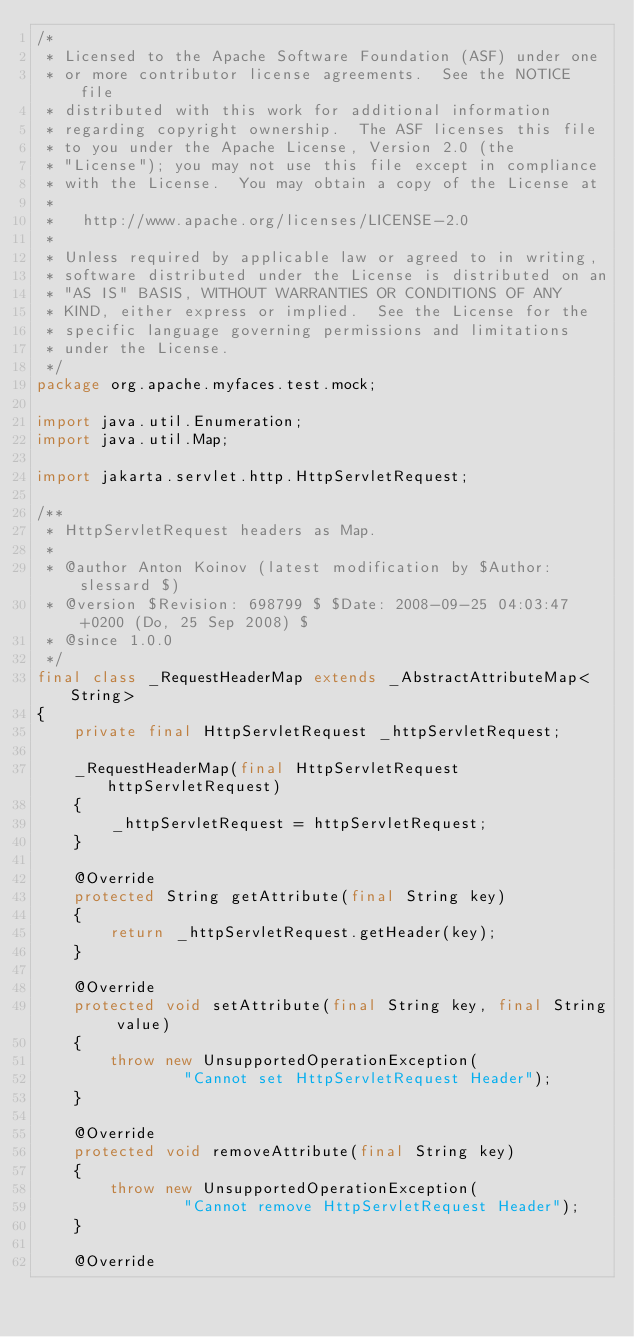Convert code to text. <code><loc_0><loc_0><loc_500><loc_500><_Java_>/*
 * Licensed to the Apache Software Foundation (ASF) under one
 * or more contributor license agreements.  See the NOTICE file
 * distributed with this work for additional information
 * regarding copyright ownership.  The ASF licenses this file
 * to you under the Apache License, Version 2.0 (the
 * "License"); you may not use this file except in compliance
 * with the License.  You may obtain a copy of the License at
 *
 *   http://www.apache.org/licenses/LICENSE-2.0
 *
 * Unless required by applicable law or agreed to in writing,
 * software distributed under the License is distributed on an
 * "AS IS" BASIS, WITHOUT WARRANTIES OR CONDITIONS OF ANY
 * KIND, either express or implied.  See the License for the
 * specific language governing permissions and limitations
 * under the License.
 */
package org.apache.myfaces.test.mock;

import java.util.Enumeration;
import java.util.Map;

import jakarta.servlet.http.HttpServletRequest;

/**
 * HttpServletRequest headers as Map.
 * 
 * @author Anton Koinov (latest modification by $Author: slessard $)
 * @version $Revision: 698799 $ $Date: 2008-09-25 04:03:47 +0200 (Do, 25 Sep 2008) $
 * @since 1.0.0
 */
final class _RequestHeaderMap extends _AbstractAttributeMap<String>
{
    private final HttpServletRequest _httpServletRequest;

    _RequestHeaderMap(final HttpServletRequest httpServletRequest)
    {
        _httpServletRequest = httpServletRequest;
    }

    @Override
    protected String getAttribute(final String key)
    {
        return _httpServletRequest.getHeader(key);
    }

    @Override
    protected void setAttribute(final String key, final String value)
    {
        throw new UnsupportedOperationException(
                "Cannot set HttpServletRequest Header");
    }

    @Override
    protected void removeAttribute(final String key)
    {
        throw new UnsupportedOperationException(
                "Cannot remove HttpServletRequest Header");
    }

    @Override</code> 